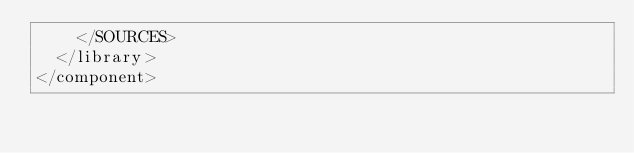Convert code to text. <code><loc_0><loc_0><loc_500><loc_500><_XML_>    </SOURCES>
  </library>
</component></code> 